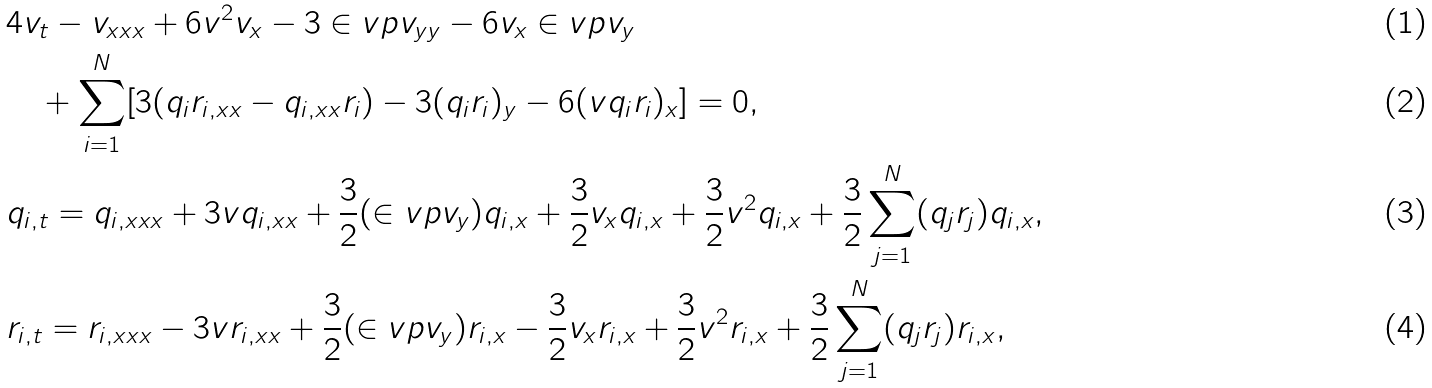Convert formula to latex. <formula><loc_0><loc_0><loc_500><loc_500>& 4 v _ { t } - v _ { x x x } + 6 v ^ { 2 } v _ { x } - 3 \in v p v _ { y y } - 6 v _ { x } \in v p v _ { y } \\ & \quad + \sum _ { i = 1 } ^ { N } [ 3 ( q _ { i } r _ { i , x x } - q _ { i , x x } r _ { i } ) - 3 ( q _ { i } r _ { i } ) _ { y } - 6 ( v q _ { i } r _ { i } ) _ { x } ] = 0 , \\ & q _ { i , t } = q _ { i , x x x } + 3 v q _ { i , x x } + \frac { 3 } { 2 } ( \in v p v _ { y } ) q _ { i , x } + \frac { 3 } { 2 } v _ { x } q _ { i , x } + \frac { 3 } { 2 } v ^ { 2 } q _ { i , x } + \frac { 3 } { 2 } \sum _ { j = 1 } ^ { N } ( q _ { j } r _ { j } ) q _ { i , x } , \\ & r _ { i , t } = r _ { i , x x x } - 3 v r _ { i , x x } + \frac { 3 } { 2 } ( \in v p v _ { y } ) r _ { i , x } - \frac { 3 } { 2 } v _ { x } r _ { i , x } + \frac { 3 } { 2 } v ^ { 2 } r _ { i , x } + \frac { 3 } { 2 } \sum _ { j = 1 } ^ { N } ( q _ { j } r _ { j } ) r _ { i , x } ,</formula> 